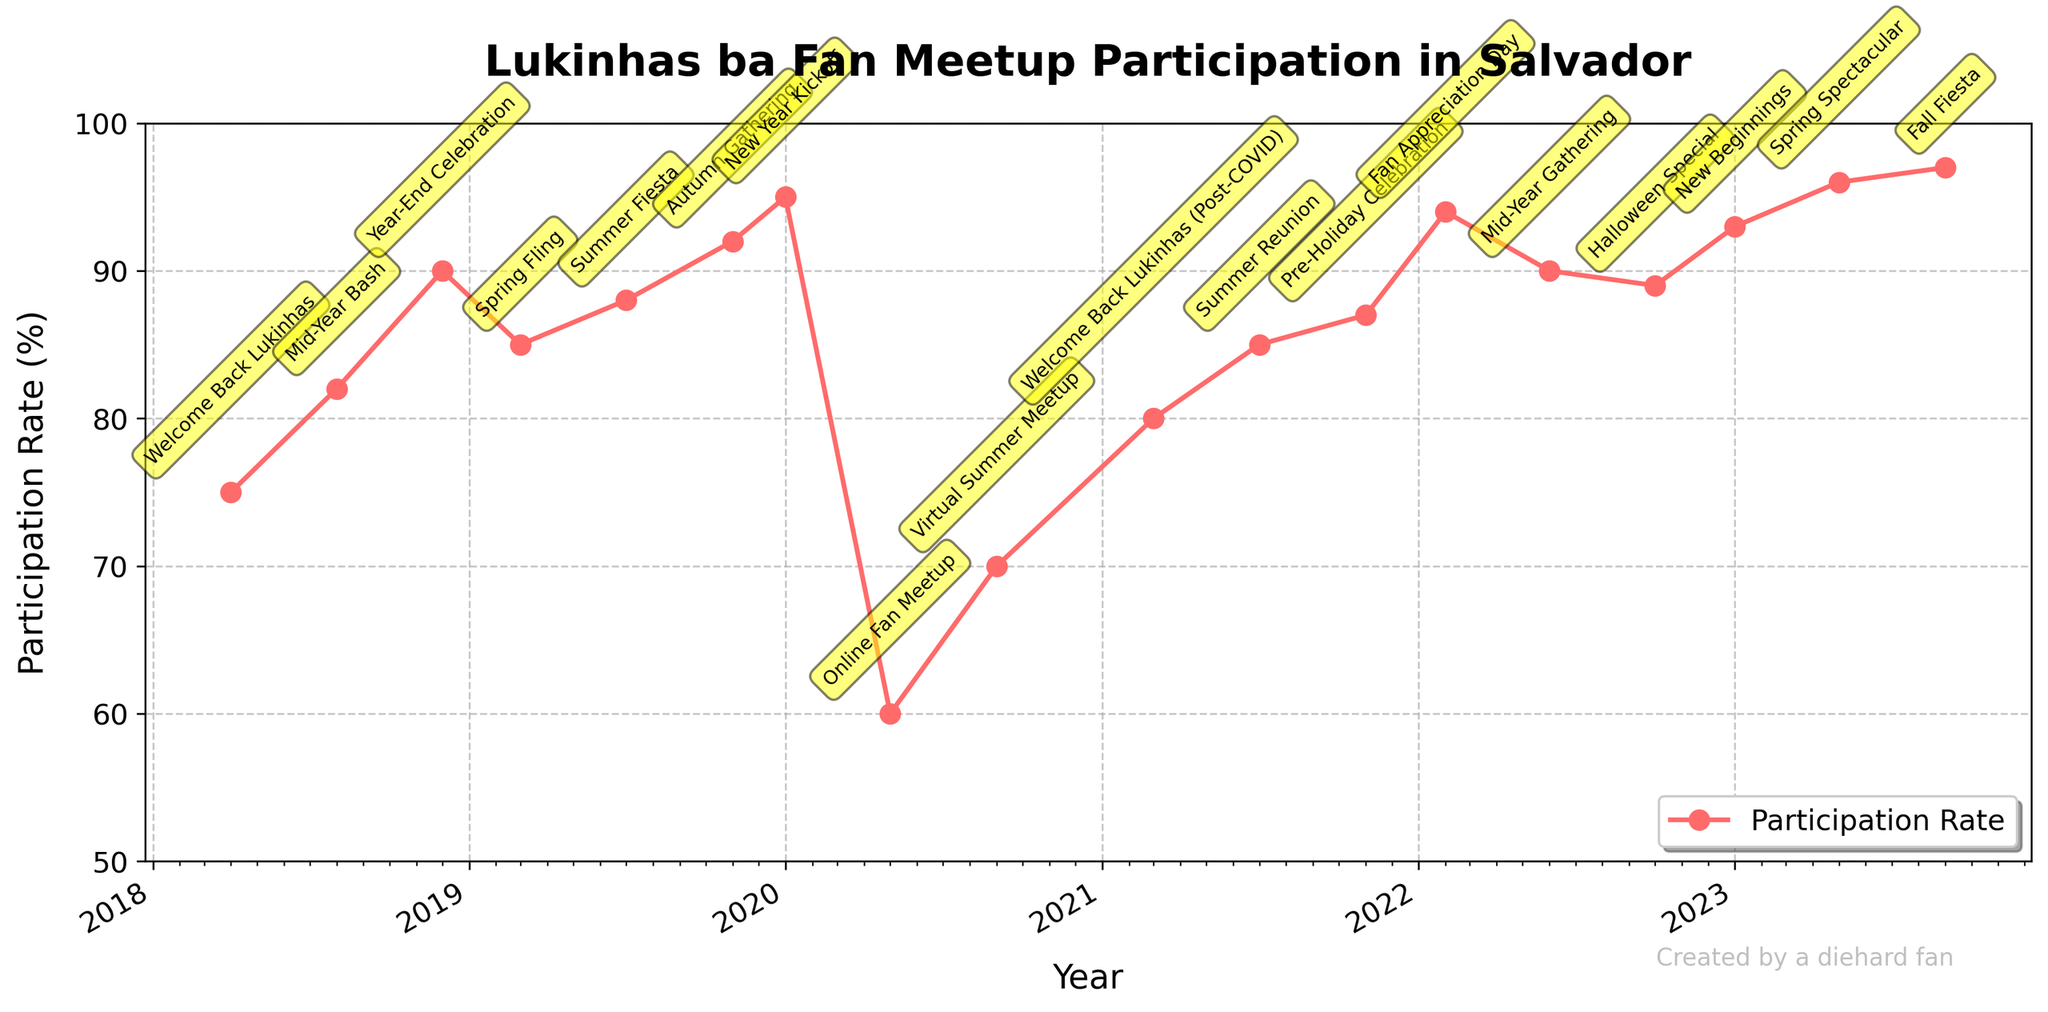What is the title of the figure? The title of the figure is located at the top, indicating the main subject of the plot. In this case, the title is "Lukinhas ba Fan Meetup Participation in Salvador."
Answer: Lukinhas ba Fan Meetup Participation in Salvador What is the participation rate for the New Year Kickoff event in January 2020? Locate the New Year Kickoff event on the x-axis corresponding to January 2020, then check the y-axis value for the participation rate.
Answer: 95% Which event had the lowest participation rate and what was the rate? Find the data point with the lowest y-axis value representing the participation rate. The lowest rate is for the Online Fan Meetup in May 2020.
Answer: Online Fan Meetup, 60% How many events had a participation rate greater than 90%? Count the number of data points with y-axis values (participation rates) exceeding 90%.
Answer: 6 How did the participation rate change from the Year-End Celebration in December 2018 to the Spring Fling in March 2019? First, identify the participation rate for both events: 90% for December 2018 and 85% for March 2019. Then, calculate the difference: 90 - 85.
Answer: Decreased by 5% Which event had the highest participation rate, and in which month and year did it occur? Find the data point with the highest y-axis value indicating the highest participation rate. The Fall Fiesta event in September 2023 had the highest rate.
Answer: Fall Fiesta, September 2023 What was the overall trend in participation rates from 2018 to 2023? Observe the plotted line over the specified period. Note whether the participation rates generally increased, decreased, or fluctuated without a clear trend.
Answer: Increasing trend Compare the participation rates of the Summer Fiesta in July 2019 to the Halloween Special in October 2022. Identify the participation rates for both events: 88% for Summer Fiesta and 89% for Halloween Special. Then, compare these two values.
Answer: Halloween Special had a higher rate What is the average participation rate for fan meetups from 2020 onwards? Identify all participation rates from January 2020 to September 2023. Add these rates and divide by the number of events in this period: (95 + 60 + 70 + 80 + 85 + 87 + 94 + 90 + 89 + 93 + 96 + 97) / 12.
Answer: 86.5% What was the participation rate for the first fan meetup event after the COVID pandemic? Identify the event "Welcome Back Lukinhas (Post-COVID)" in March 2021 and check its participation rate.
Answer: 80% 